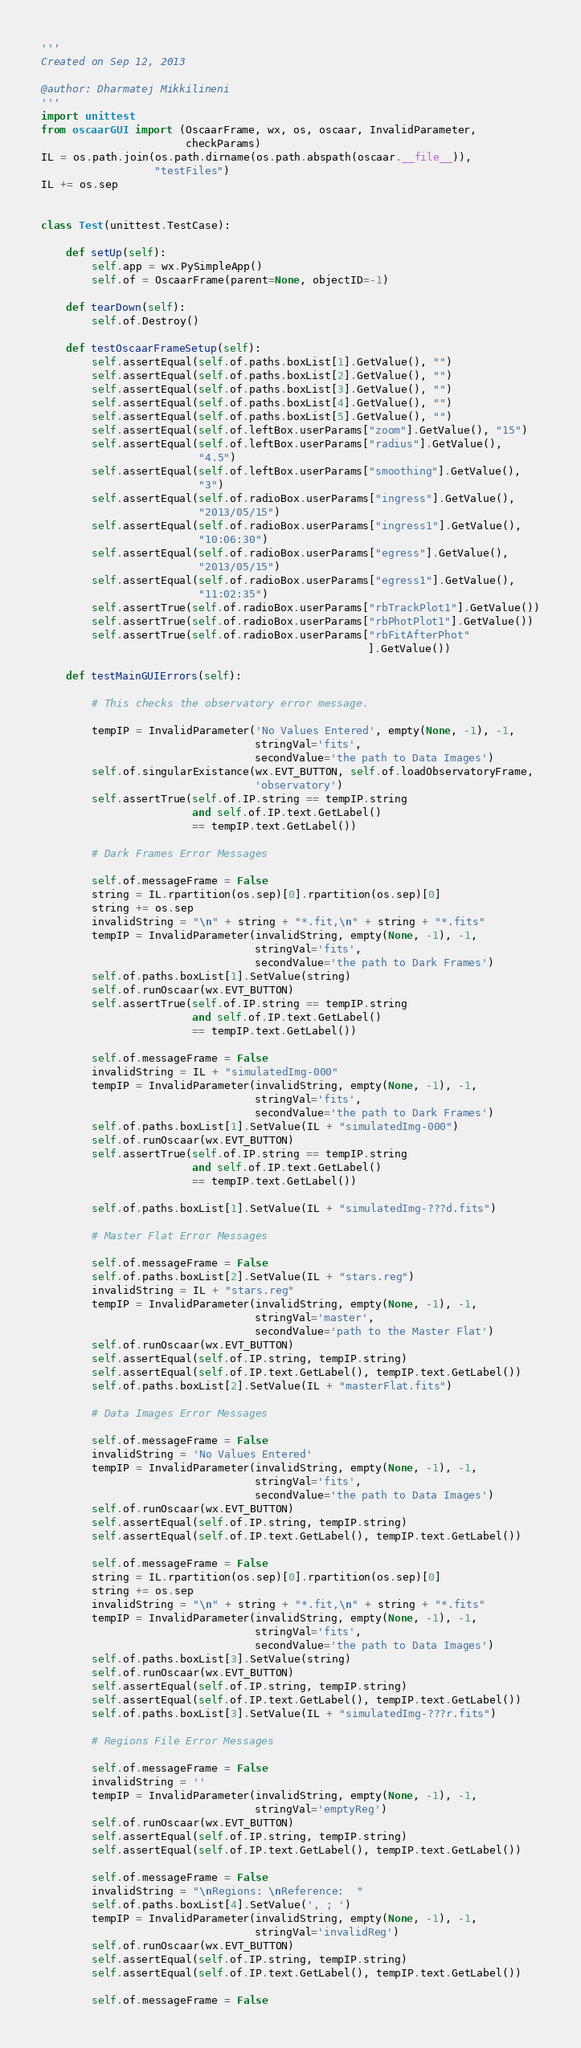<code> <loc_0><loc_0><loc_500><loc_500><_Python_>'''
Created on Sep 12, 2013

@author: Dharmatej Mikkilineni
'''
import unittest
from oscaarGUI import (OscaarFrame, wx, os, oscaar, InvalidParameter,
                       checkParams)
IL = os.path.join(os.path.dirname(os.path.abspath(oscaar.__file__)),
                  "testFiles")
IL += os.sep


class Test(unittest.TestCase):

    def setUp(self):
        self.app = wx.PySimpleApp()
        self.of = OscaarFrame(parent=None, objectID=-1)

    def tearDown(self):
        self.of.Destroy()

    def testOscaarFrameSetup(self):
        self.assertEqual(self.of.paths.boxList[1].GetValue(), "")
        self.assertEqual(self.of.paths.boxList[2].GetValue(), "")
        self.assertEqual(self.of.paths.boxList[3].GetValue(), "")
        self.assertEqual(self.of.paths.boxList[4].GetValue(), "")
        self.assertEqual(self.of.paths.boxList[5].GetValue(), "")
        self.assertEqual(self.of.leftBox.userParams["zoom"].GetValue(), "15")
        self.assertEqual(self.of.leftBox.userParams["radius"].GetValue(),
                         "4.5")
        self.assertEqual(self.of.leftBox.userParams["smoothing"].GetValue(),
                         "3")
        self.assertEqual(self.of.radioBox.userParams["ingress"].GetValue(),
                         "2013/05/15")
        self.assertEqual(self.of.radioBox.userParams["ingress1"].GetValue(),
                         "10:06:30")
        self.assertEqual(self.of.radioBox.userParams["egress"].GetValue(),
                         "2013/05/15")
        self.assertEqual(self.of.radioBox.userParams["egress1"].GetValue(),
                         "11:02:35")
        self.assertTrue(self.of.radioBox.userParams["rbTrackPlot1"].GetValue())
        self.assertTrue(self.of.radioBox.userParams["rbPhotPlot1"].GetValue())
        self.assertTrue(self.of.radioBox.userParams["rbFitAfterPhot"
                                                    ].GetValue())

    def testMainGUIErrors(self):

        # This checks the observatory error message.

        tempIP = InvalidParameter('No Values Entered', empty(None, -1), -1,
                                  stringVal='fits',
                                  secondValue='the path to Data Images')
        self.of.singularExistance(wx.EVT_BUTTON, self.of.loadObservatoryFrame,
                                  'observatory')
        self.assertTrue(self.of.IP.string == tempIP.string
                        and self.of.IP.text.GetLabel()
                        == tempIP.text.GetLabel())

        # Dark Frames Error Messages

        self.of.messageFrame = False
        string = IL.rpartition(os.sep)[0].rpartition(os.sep)[0]
        string += os.sep
        invalidString = "\n" + string + "*.fit,\n" + string + "*.fits"
        tempIP = InvalidParameter(invalidString, empty(None, -1), -1,
                                  stringVal='fits',
                                  secondValue='the path to Dark Frames')
        self.of.paths.boxList[1].SetValue(string)
        self.of.runOscaar(wx.EVT_BUTTON)
        self.assertTrue(self.of.IP.string == tempIP.string
                        and self.of.IP.text.GetLabel()
                        == tempIP.text.GetLabel())

        self.of.messageFrame = False
        invalidString = IL + "simulatedImg-000"
        tempIP = InvalidParameter(invalidString, empty(None, -1), -1,
                                  stringVal='fits',
                                  secondValue='the path to Dark Frames')
        self.of.paths.boxList[1].SetValue(IL + "simulatedImg-000")
        self.of.runOscaar(wx.EVT_BUTTON)
        self.assertTrue(self.of.IP.string == tempIP.string
                        and self.of.IP.text.GetLabel()
                        == tempIP.text.GetLabel())

        self.of.paths.boxList[1].SetValue(IL + "simulatedImg-???d.fits")

        # Master Flat Error Messages

        self.of.messageFrame = False
        self.of.paths.boxList[2].SetValue(IL + "stars.reg")
        invalidString = IL + "stars.reg"
        tempIP = InvalidParameter(invalidString, empty(None, -1), -1,
                                  stringVal='master',
                                  secondValue='path to the Master Flat')
        self.of.runOscaar(wx.EVT_BUTTON)
        self.assertEqual(self.of.IP.string, tempIP.string)
        self.assertEqual(self.of.IP.text.GetLabel(), tempIP.text.GetLabel())
        self.of.paths.boxList[2].SetValue(IL + "masterFlat.fits")

        # Data Images Error Messages

        self.of.messageFrame = False
        invalidString = 'No Values Entered'
        tempIP = InvalidParameter(invalidString, empty(None, -1), -1,
                                  stringVal='fits',
                                  secondValue='the path to Data Images')
        self.of.runOscaar(wx.EVT_BUTTON)
        self.assertEqual(self.of.IP.string, tempIP.string)
        self.assertEqual(self.of.IP.text.GetLabel(), tempIP.text.GetLabel())

        self.of.messageFrame = False
        string = IL.rpartition(os.sep)[0].rpartition(os.sep)[0]
        string += os.sep
        invalidString = "\n" + string + "*.fit,\n" + string + "*.fits"
        tempIP = InvalidParameter(invalidString, empty(None, -1), -1,
                                  stringVal='fits',
                                  secondValue='the path to Data Images')
        self.of.paths.boxList[3].SetValue(string)
        self.of.runOscaar(wx.EVT_BUTTON)
        self.assertEqual(self.of.IP.string, tempIP.string)
        self.assertEqual(self.of.IP.text.GetLabel(), tempIP.text.GetLabel())
        self.of.paths.boxList[3].SetValue(IL + "simulatedImg-???r.fits")

        # Regions File Error Messages

        self.of.messageFrame = False
        invalidString = ''
        tempIP = InvalidParameter(invalidString, empty(None, -1), -1,
                                  stringVal='emptyReg')
        self.of.runOscaar(wx.EVT_BUTTON)
        self.assertEqual(self.of.IP.string, tempIP.string)
        self.assertEqual(self.of.IP.text.GetLabel(), tempIP.text.GetLabel())

        self.of.messageFrame = False
        invalidString = "\nRegions: \nReference:  "
        self.of.paths.boxList[4].SetValue(', ; ')
        tempIP = InvalidParameter(invalidString, empty(None, -1), -1,
                                  stringVal='invalidReg')
        self.of.runOscaar(wx.EVT_BUTTON)
        self.assertEqual(self.of.IP.string, tempIP.string)
        self.assertEqual(self.of.IP.text.GetLabel(), tempIP.text.GetLabel())

        self.of.messageFrame = False</code> 